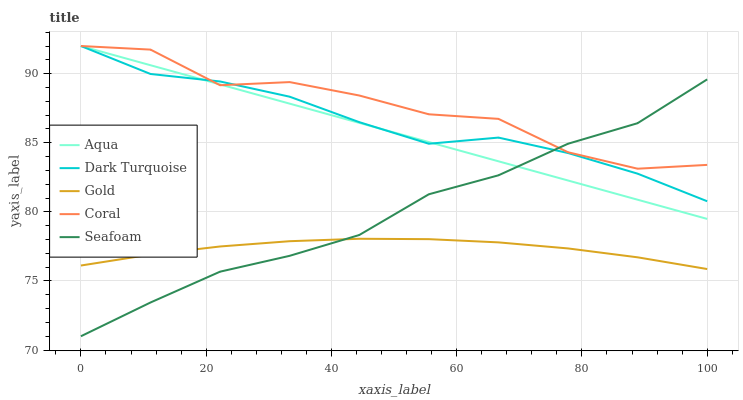Does Gold have the minimum area under the curve?
Answer yes or no. Yes. Does Coral have the maximum area under the curve?
Answer yes or no. Yes. Does Aqua have the minimum area under the curve?
Answer yes or no. No. Does Aqua have the maximum area under the curve?
Answer yes or no. No. Is Aqua the smoothest?
Answer yes or no. Yes. Is Coral the roughest?
Answer yes or no. Yes. Is Coral the smoothest?
Answer yes or no. No. Is Aqua the roughest?
Answer yes or no. No. Does Aqua have the lowest value?
Answer yes or no. No. Does Aqua have the highest value?
Answer yes or no. Yes. Does Seafoam have the highest value?
Answer yes or no. No. Is Gold less than Coral?
Answer yes or no. Yes. Is Dark Turquoise greater than Gold?
Answer yes or no. Yes. Does Coral intersect Dark Turquoise?
Answer yes or no. Yes. Is Coral less than Dark Turquoise?
Answer yes or no. No. Is Coral greater than Dark Turquoise?
Answer yes or no. No. Does Gold intersect Coral?
Answer yes or no. No. 